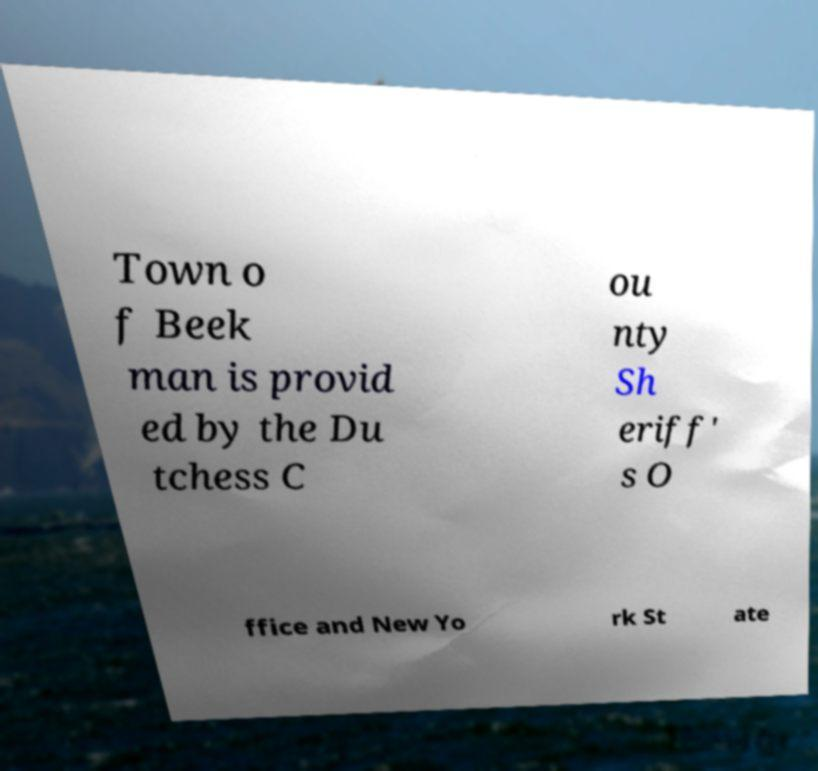I need the written content from this picture converted into text. Can you do that? Town o f Beek man is provid ed by the Du tchess C ou nty Sh eriff' s O ffice and New Yo rk St ate 